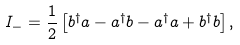Convert formula to latex. <formula><loc_0><loc_0><loc_500><loc_500>I _ { - } = \frac { 1 } { 2 } \left [ b ^ { \dag } a - a ^ { \dag } b - a ^ { \dag } a + b ^ { \dag } b \right ] ,</formula> 